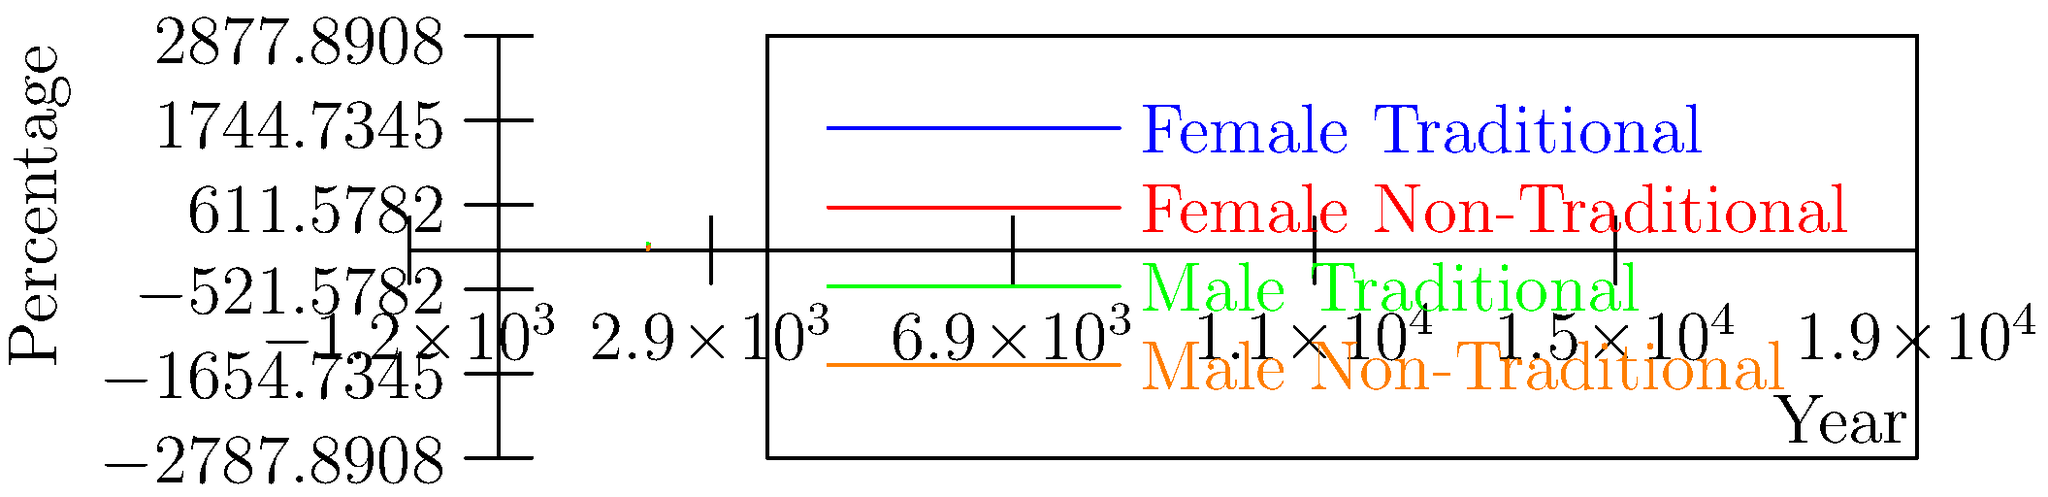Analyze the graph showing the evolution of character clothing styles in relation to gender roles in a popular novel series from 1997 to 2017. What trend does this data suggest about the author's approach to challenging gender stereotypes through character clothing, and how does it relate to the percentage of non-traditional clothing choices for female characters in 2017? To answer this question, let's analyze the graph step-by-step:

1. Observe the trends for each category:
   - Female Traditional: Decreasing from 80% to 25%
   - Female Non-Traditional: Increasing from 20% to 75%
   - Male Traditional: Decreasing from 90% to 55%
   - Male Non-Traditional: Increasing from 10% to 45%

2. Note the overall trend:
   Both male and female characters show a shift from traditional to non-traditional clothing styles over time.

3. Compare the rate of change:
   The change is more pronounced for female characters, with a steeper slope for both traditional and non-traditional lines.

4. Analyze the final percentages in 2017:
   - Female Non-Traditional: 75%
   - Male Non-Traditional: 45%

5. Interpret the data:
   The author appears to be consistently challenging gender stereotypes through character clothing, with a more significant emphasis on female characters.

6. Focus on the question about female non-traditional clothing in 2017:
   The percentage of female characters in non-traditional clothing reaches 75% by 2017.

This trend suggests that the author is actively challenging gender stereotypes by increasingly portraying characters, especially female ones, in non-traditional clothing. The high percentage (75%) of female characters in non-traditional clothing by 2017 indicates a strong commitment to this approach.
Answer: The author increasingly challenges gender stereotypes through character clothing, with 75% of female characters in non-traditional attire by 2017. 